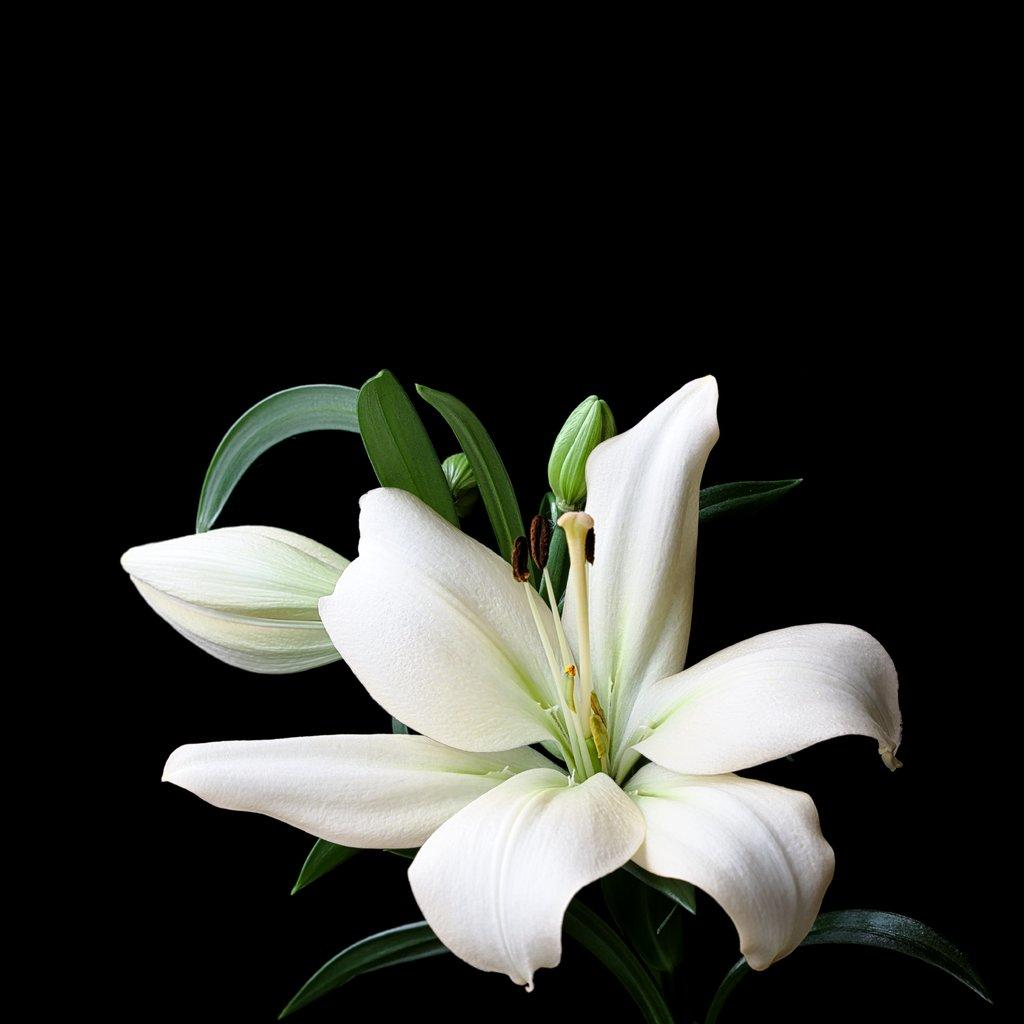What type of plants can be seen in the image? There are flowers in the image. Can you describe any specific features of the flowers? There is a bud on the stem of a plant in the image. What type of crime is being committed in the image? There is no crime present in the image; it features flowers and a bud on a plant. Can you describe the battle taking place in the image? There is no battle present in the image; it features flowers and a bud on a plant. 